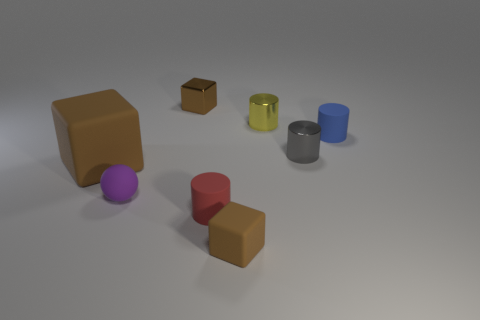Add 1 matte cylinders. How many objects exist? 9 Subtract all blocks. How many objects are left? 5 Add 1 tiny yellow things. How many tiny yellow things are left? 2 Add 4 small rubber things. How many small rubber things exist? 8 Subtract 1 red cylinders. How many objects are left? 7 Subtract all small blue shiny things. Subtract all small blue rubber things. How many objects are left? 7 